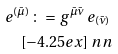Convert formula to latex. <formula><loc_0><loc_0><loc_500><loc_500>e ^ { ( \bar { \mu } ) } \, \colon = \, g ^ { \bar { \mu } \bar { \nu } } \, e _ { ( \bar { \nu } ) } \, \\ [ - 4 . 2 5 e x ] \ n n</formula> 